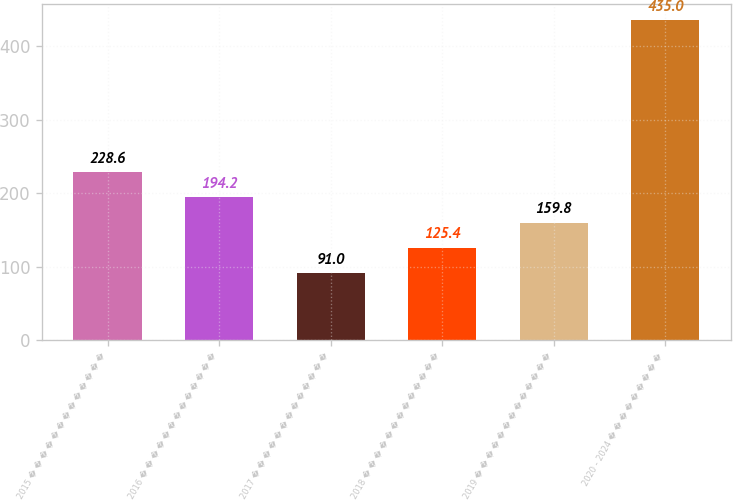Convert chart to OTSL. <chart><loc_0><loc_0><loc_500><loc_500><bar_chart><fcel>2015 � � � � � � � � � � � � �<fcel>2016 � � � � � � � � � � � � �<fcel>2017 � � � � � � � � � � � � �<fcel>2018 � � � � � � � � � � � � �<fcel>2019 � � � � � � � � � � � � �<fcel>2020 - 2024 � � � � � � � � �<nl><fcel>228.6<fcel>194.2<fcel>91<fcel>125.4<fcel>159.8<fcel>435<nl></chart> 